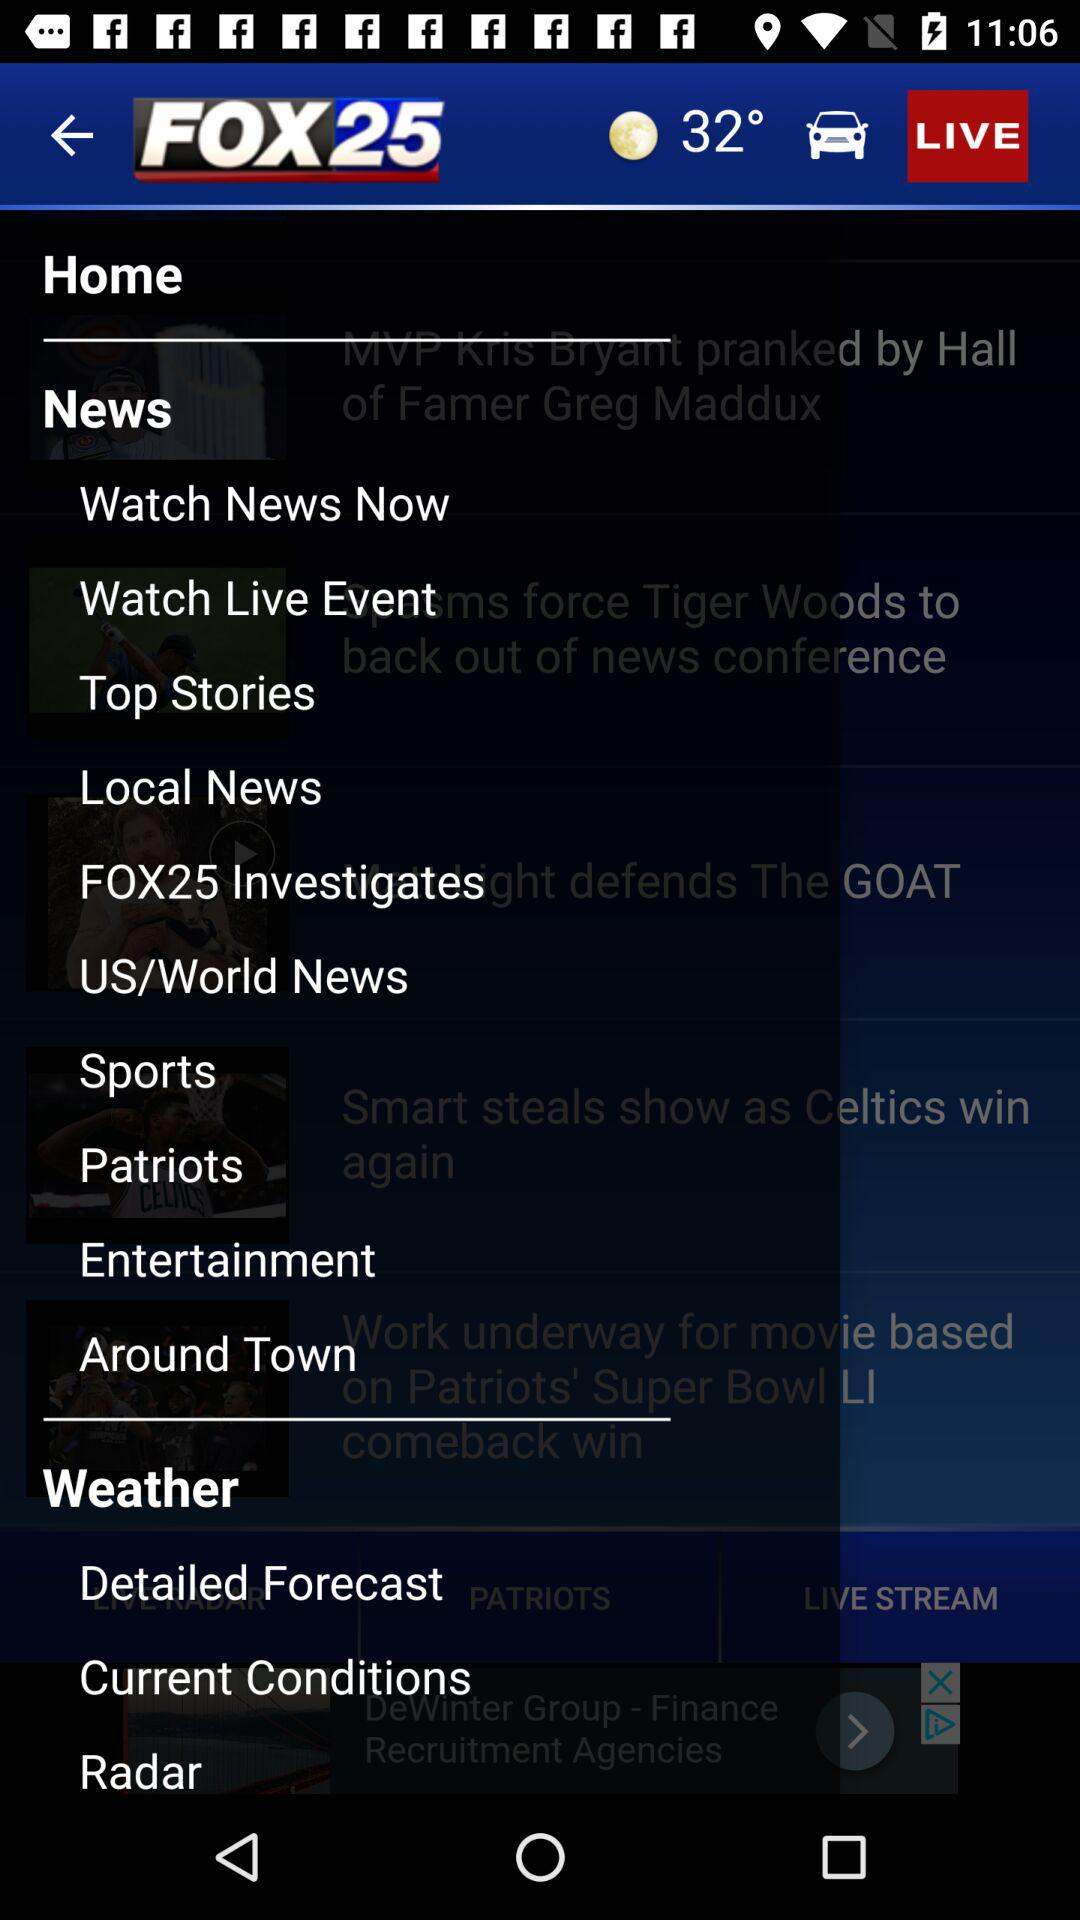What is the temperature shown on the screen? The temperature shown on the screen is 32°. 